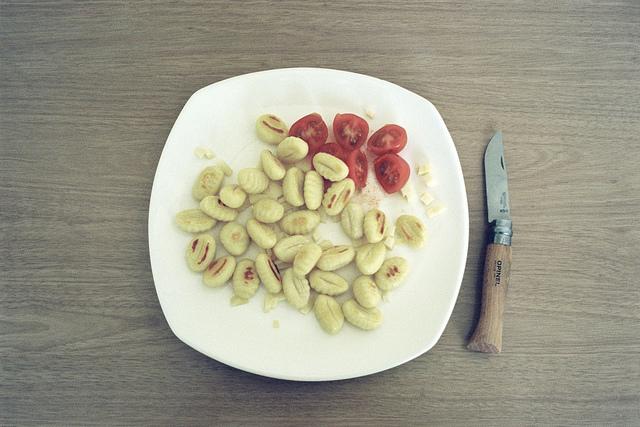What kind of food is on the plate?
Quick response, please. Tomatoes. What type of pasta meal is on the table?
Give a very brief answer. Gnocchi. What shape is the plate?
Short answer required. Square. What is the orange veggie?
Answer briefly. Tomato. What is the handle of the knife made of?
Keep it brief. Wood. 